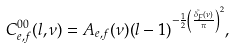<formula> <loc_0><loc_0><loc_500><loc_500>C ^ { 0 0 } _ { e , f } ( l , \nu ) = A _ { e , f } ( \nu ) ( l - 1 ) ^ { - \frac { 1 } { 2 } \left ( \frac { \tilde { \delta _ { F } } ( \nu ) } { \pi } \right ) ^ { 2 } } ,</formula> 